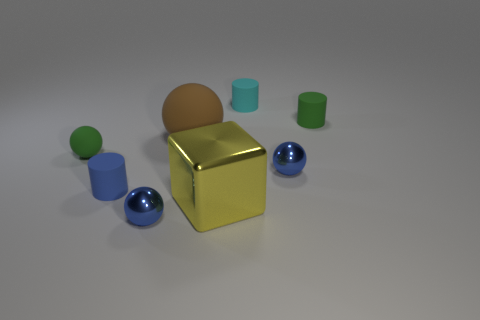What objects can you identify in the image? In the image, there are several objects including a large yellow cube, a small cyan cylinder, a green cylinder, a smaller blue cylinder, a blue sphere, and a brown sphere. Can you tell me which object appears the most reflective? The most reflective object appears to be the yellow cube, which shows a high level of glossiness indicating its reflective surface. 